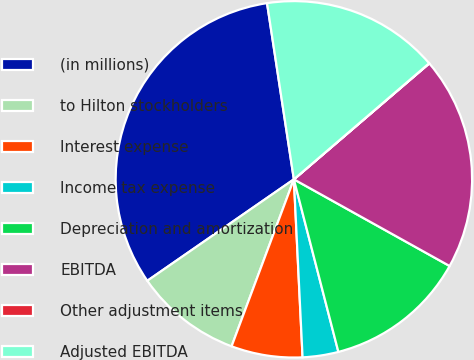Convert chart. <chart><loc_0><loc_0><loc_500><loc_500><pie_chart><fcel>(in millions)<fcel>to Hilton stockholders<fcel>Interest expense<fcel>Income tax expense<fcel>Depreciation and amortization<fcel>EBITDA<fcel>Other adjustment items<fcel>Adjusted EBITDA<nl><fcel>32.23%<fcel>9.68%<fcel>6.46%<fcel>3.24%<fcel>12.9%<fcel>19.35%<fcel>0.02%<fcel>16.12%<nl></chart> 